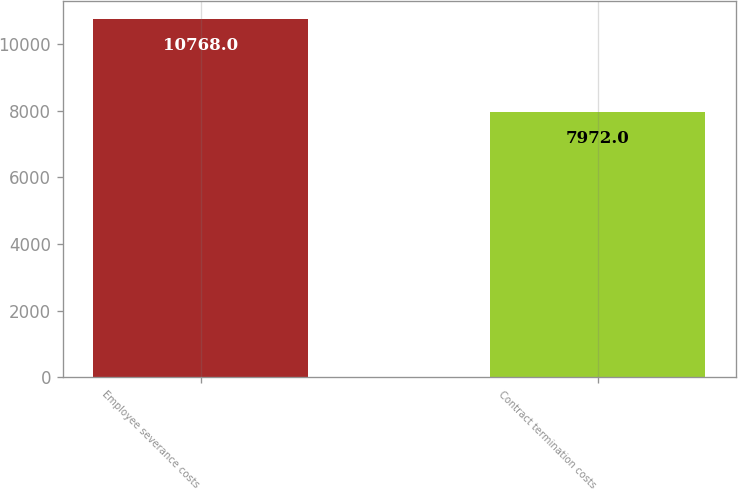<chart> <loc_0><loc_0><loc_500><loc_500><bar_chart><fcel>Employee severance costs<fcel>Contract termination costs<nl><fcel>10768<fcel>7972<nl></chart> 